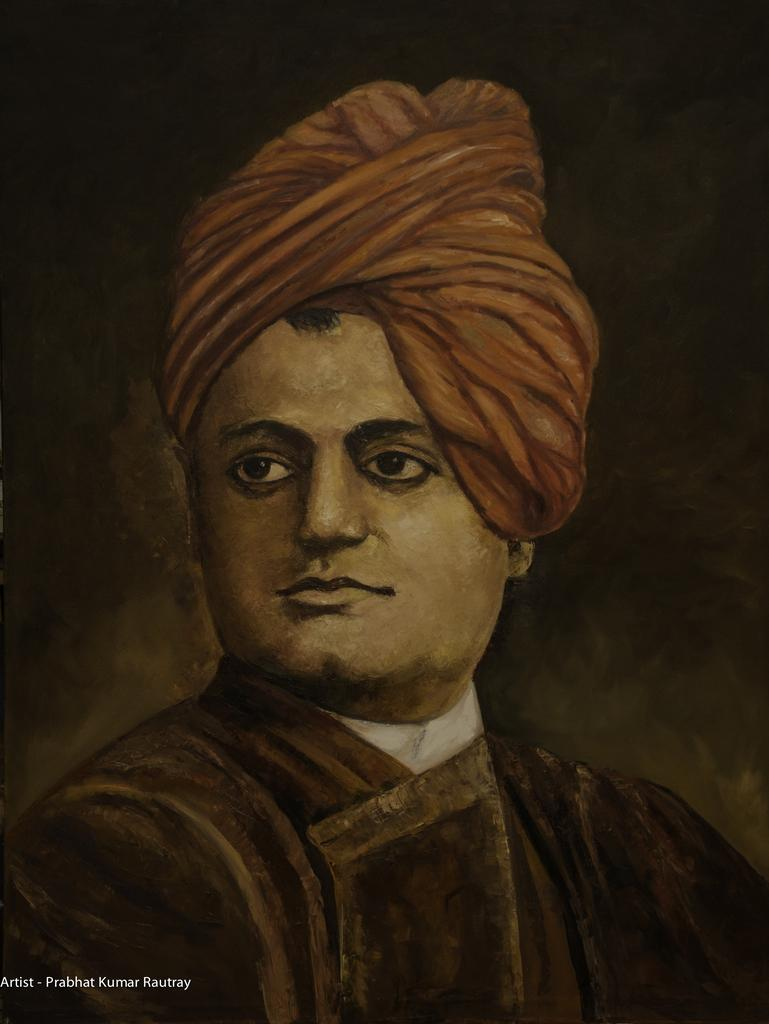What is depicted in the painting in the image? There is a painting of a person in the image. What color is the background of the painting? The background of the painting is black. Where can some text be found in the image? There is some text in the bottom left corner of the image. How many jewels are scattered around the person in the painting? There are no jewels present in the painting or the image. What type of rice is being cooked in the background of the painting? There is no rice depicted in the painting or the image. 